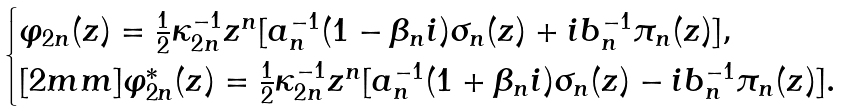<formula> <loc_0><loc_0><loc_500><loc_500>\begin{cases} \varphi _ { 2 n } ( z ) = \frac { 1 } { 2 } \kappa ^ { - 1 } _ { 2 n } z ^ { n } [ a ^ { - 1 } _ { n } ( 1 - \beta _ { n } i ) \sigma _ { n } ( z ) + i b ^ { - 1 } _ { n } \pi _ { n } ( z ) ] , \\ [ 2 m m ] \varphi ^ { * } _ { 2 n } ( z ) = \frac { 1 } { 2 } \kappa ^ { - 1 } _ { 2 n } z ^ { n } [ a ^ { - 1 } _ { n } ( 1 + \beta _ { n } i ) \sigma _ { n } ( z ) - i b ^ { - 1 } _ { n } \pi _ { n } ( z ) ] . \end{cases}</formula> 